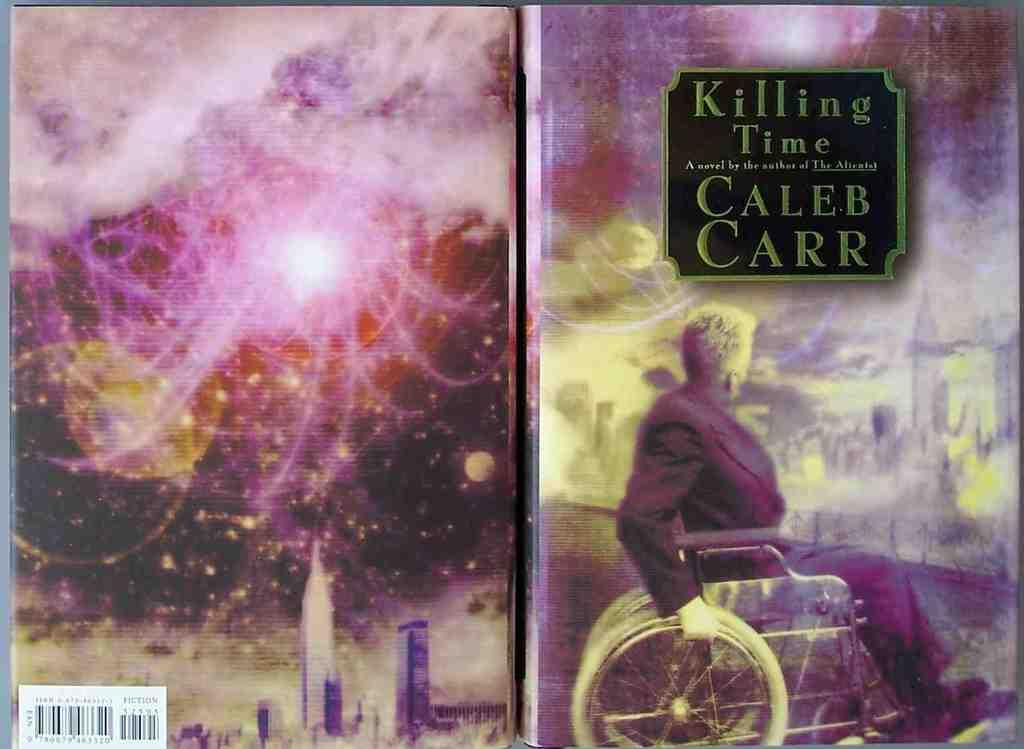<image>
Relay a brief, clear account of the picture shown. A book that is opened flat with the cover saying Killing Time Caleb Carr with back showing the scanning sticker on the back bottom. 